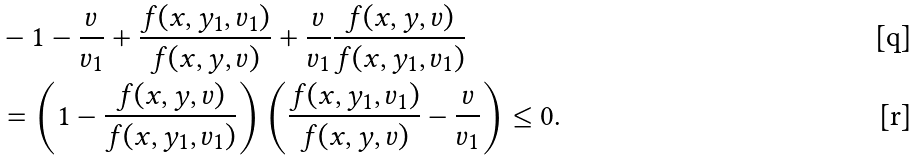<formula> <loc_0><loc_0><loc_500><loc_500>& - 1 - \frac { v } { v _ { 1 } } + \frac { f ( x , y _ { 1 } , v _ { 1 } ) } { f ( x , y , v ) } + \frac { v } { v _ { 1 } } \frac { f ( x , y , v ) } { f ( x , y _ { 1 } , v _ { 1 } ) } \\ & = \left ( 1 - \frac { f ( x , y , v ) } { f ( x , y _ { 1 } , v _ { 1 } ) } \right ) \left ( \frac { f ( x , y _ { 1 } , v _ { 1 } ) } { f ( x , y , v ) } - \frac { v } { v _ { 1 } } \right ) \leq 0 .</formula> 